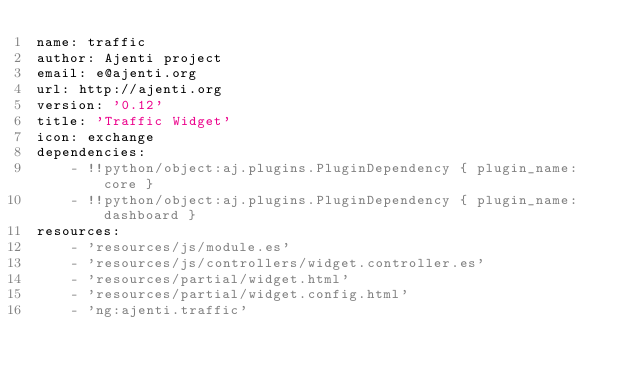Convert code to text. <code><loc_0><loc_0><loc_500><loc_500><_YAML_>name: traffic
author: Ajenti project
email: e@ajenti.org
url: http://ajenti.org
version: '0.12'
title: 'Traffic Widget'
icon: exchange
dependencies:
    - !!python/object:aj.plugins.PluginDependency { plugin_name: core }
    - !!python/object:aj.plugins.PluginDependency { plugin_name: dashboard }
resources:
    - 'resources/js/module.es'
    - 'resources/js/controllers/widget.controller.es'
    - 'resources/partial/widget.html'
    - 'resources/partial/widget.config.html'
    - 'ng:ajenti.traffic'
</code> 